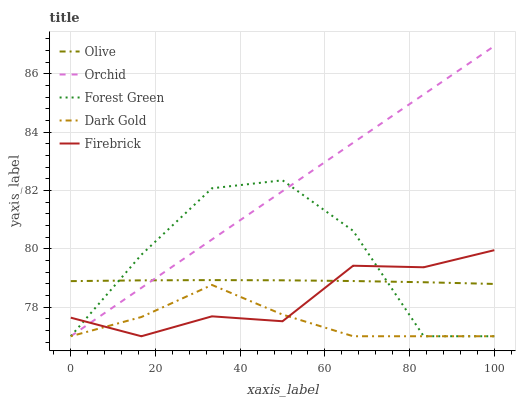Does Forest Green have the minimum area under the curve?
Answer yes or no. No. Does Forest Green have the maximum area under the curve?
Answer yes or no. No. Is Dark Gold the smoothest?
Answer yes or no. No. Is Dark Gold the roughest?
Answer yes or no. No. Does Forest Green have the highest value?
Answer yes or no. No. Is Dark Gold less than Olive?
Answer yes or no. Yes. Is Olive greater than Dark Gold?
Answer yes or no. Yes. Does Dark Gold intersect Olive?
Answer yes or no. No. 